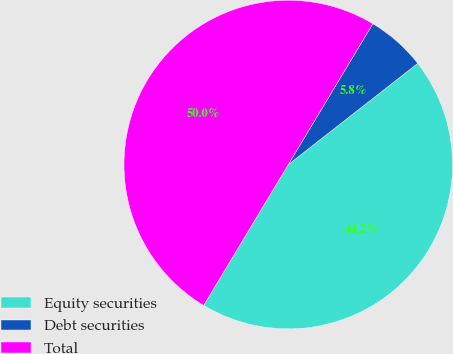<chart> <loc_0><loc_0><loc_500><loc_500><pie_chart><fcel>Equity securities<fcel>Debt securities<fcel>Total<nl><fcel>44.17%<fcel>5.83%<fcel>50.0%<nl></chart> 